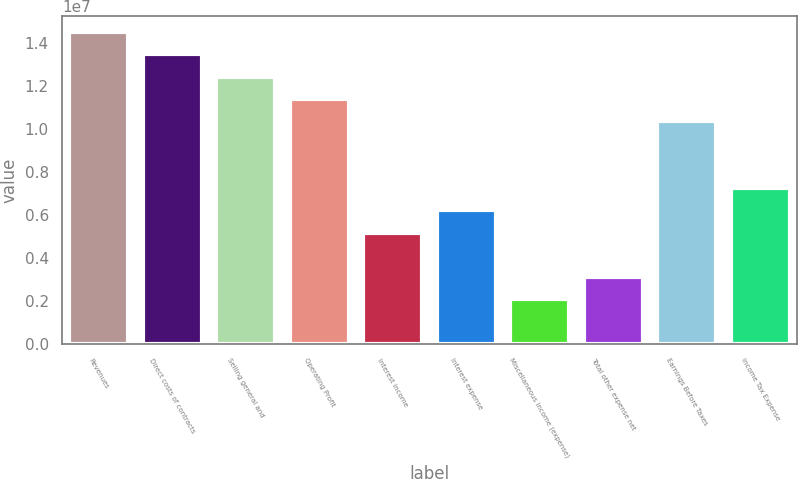Convert chart to OTSL. <chart><loc_0><loc_0><loc_500><loc_500><bar_chart><fcel>Revenues<fcel>Direct costs of contracts<fcel>Selling general and<fcel>Operating Profit<fcel>Interest income<fcel>Interest expense<fcel>Miscellaneous income (expense)<fcel>Total other expense net<fcel>Earnings Before Taxes<fcel>Income Tax Expense<nl><fcel>1.45343e+07<fcel>1.34962e+07<fcel>1.2458e+07<fcel>1.14198e+07<fcel>5.19083e+06<fcel>6.229e+06<fcel>2.07633e+06<fcel>3.1145e+06<fcel>1.03817e+07<fcel>7.26717e+06<nl></chart> 